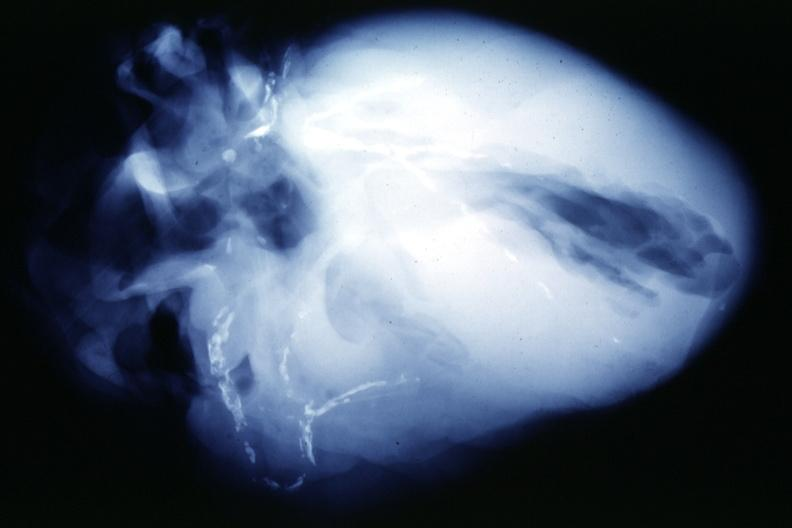what does this image show?
Answer the question using a single word or phrase. X-ray postmortextensive lesions in x-ray of whole heart 